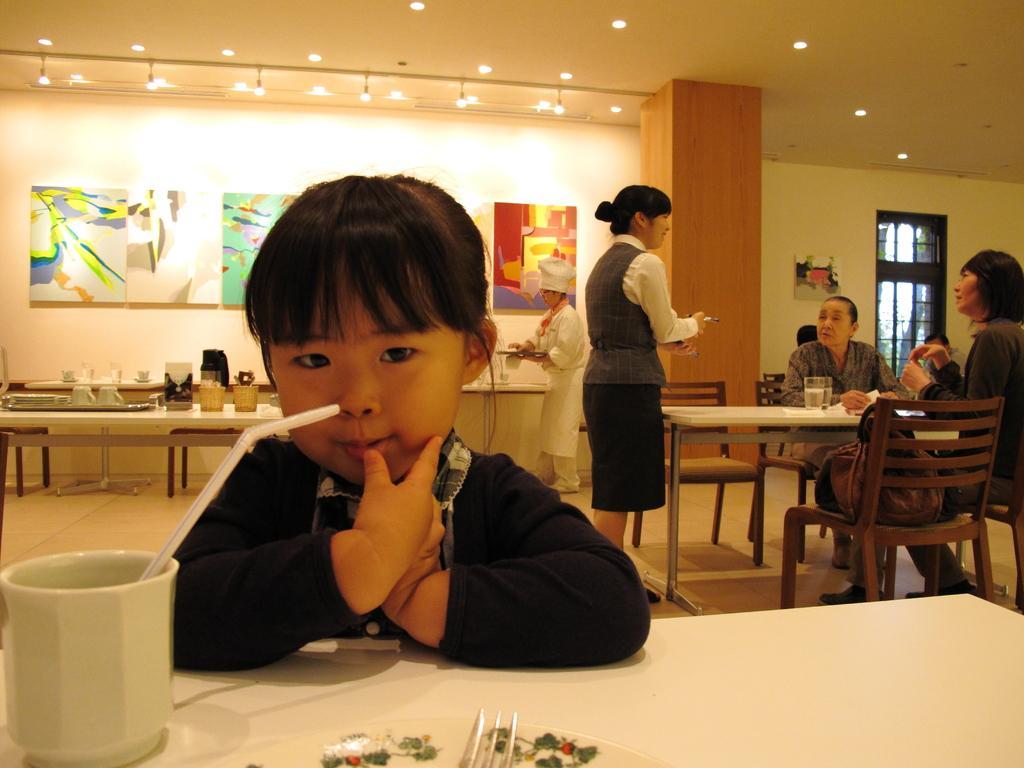Describe this image in one or two sentences. In the picture we can see some people are sitting on the chairs near the table and one girl is sitting on another chair near the table, on that table we can see a cup with straw, in the background we can see some tables and some things on it, and wall with the paintings and ceiling with the lights. 